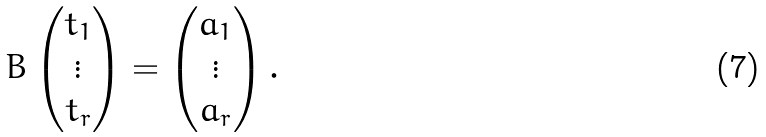Convert formula to latex. <formula><loc_0><loc_0><loc_500><loc_500>B \left ( \begin{matrix} t _ { 1 } \\ \vdots \\ t _ { r } \end{matrix} \right ) = \left ( \begin{matrix} a _ { 1 } \\ \vdots \\ a _ { r } \end{matrix} \right ) .</formula> 